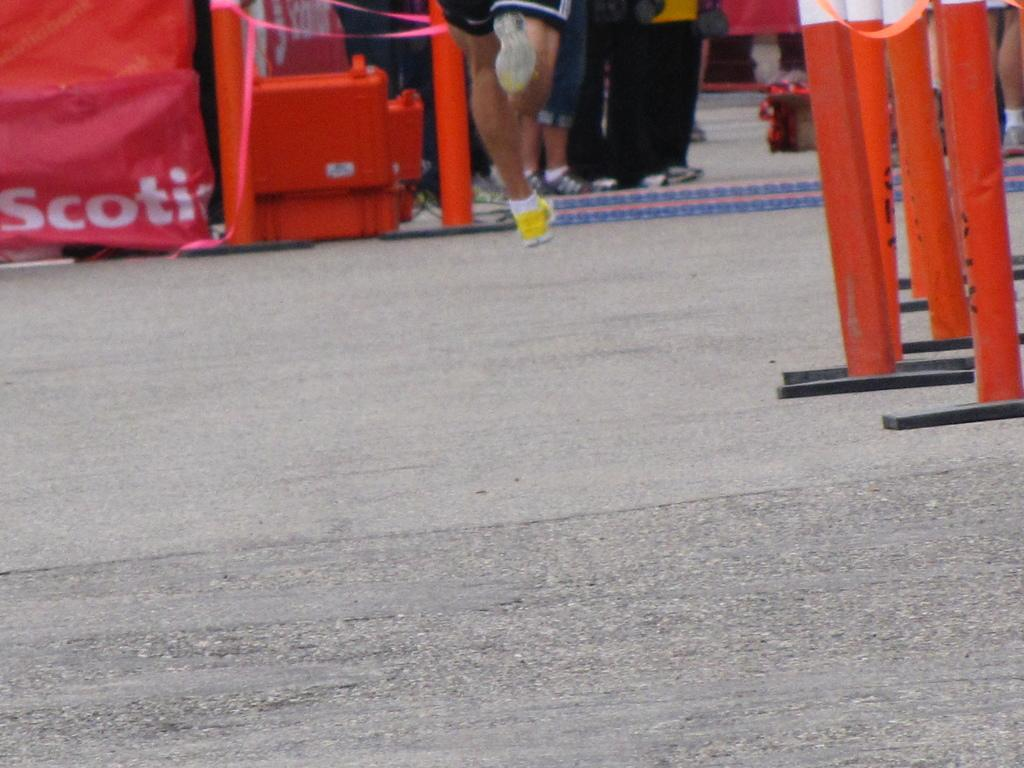What can be seen separating the lanes in the image? There are lane dividers in the image. What else can be seen in the image that might be used for safety or traffic control? There are barricades in the image. Can you describe the group of people in the image? There is a group of people in the image, but their specific actions or characteristics are not mentioned in the provided facts. What type of oven is being used by the group of people in the image? There is no oven present in the image; it features lane dividers and barricades. What color is the pen being used by the group of people in the image? There is no pen present in the image, and the actions or characteristics of the group of people are not mentioned in the provided facts. 